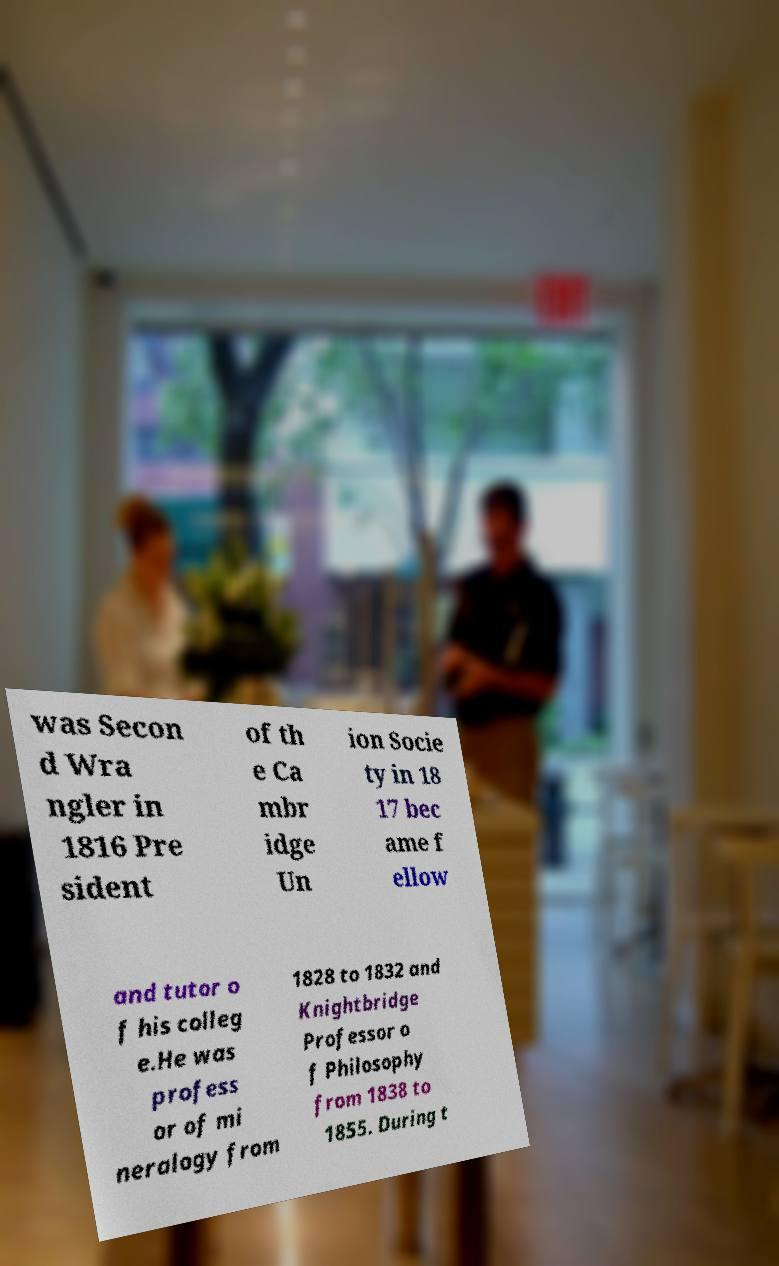Please read and relay the text visible in this image. What does it say? was Secon d Wra ngler in 1816 Pre sident of th e Ca mbr idge Un ion Socie ty in 18 17 bec ame f ellow and tutor o f his colleg e.He was profess or of mi neralogy from 1828 to 1832 and Knightbridge Professor o f Philosophy from 1838 to 1855. During t 